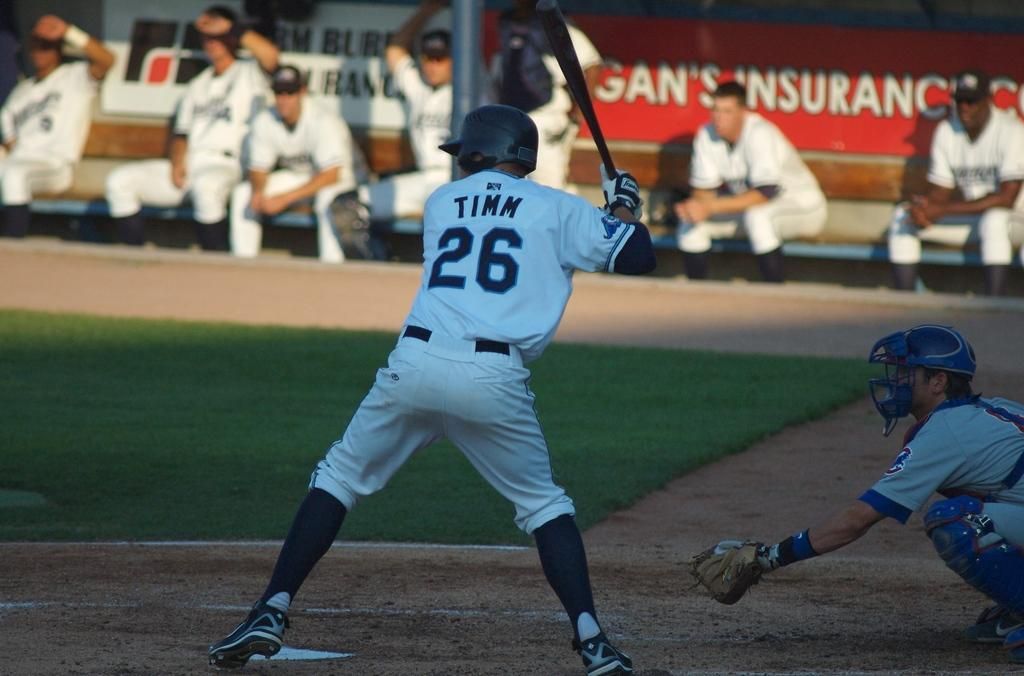<image>
Write a terse but informative summary of the picture. The player named Timm is number 26 on his baseball team. 